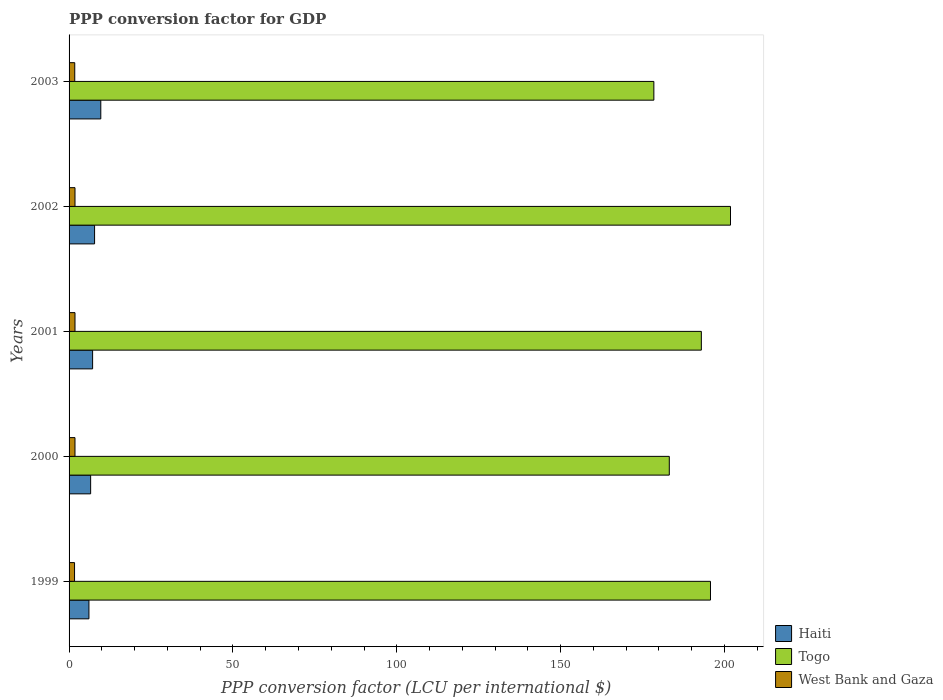How many different coloured bars are there?
Ensure brevity in your answer.  3. How many groups of bars are there?
Offer a terse response. 5. Are the number of bars per tick equal to the number of legend labels?
Your response must be concise. Yes. How many bars are there on the 2nd tick from the bottom?
Provide a succinct answer. 3. What is the label of the 5th group of bars from the top?
Your response must be concise. 1999. In how many cases, is the number of bars for a given year not equal to the number of legend labels?
Give a very brief answer. 0. What is the PPP conversion factor for GDP in West Bank and Gaza in 2001?
Keep it short and to the point. 1.81. Across all years, what is the maximum PPP conversion factor for GDP in Haiti?
Offer a terse response. 9.68. Across all years, what is the minimum PPP conversion factor for GDP in West Bank and Gaza?
Your answer should be very brief. 1.67. In which year was the PPP conversion factor for GDP in Togo maximum?
Provide a succinct answer. 2002. What is the total PPP conversion factor for GDP in Haiti in the graph?
Provide a short and direct response. 37.29. What is the difference between the PPP conversion factor for GDP in Togo in 1999 and that in 2002?
Offer a very short reply. -6.11. What is the difference between the PPP conversion factor for GDP in Haiti in 2000 and the PPP conversion factor for GDP in West Bank and Gaza in 2001?
Keep it short and to the point. 4.77. What is the average PPP conversion factor for GDP in West Bank and Gaza per year?
Offer a very short reply. 1.77. In the year 2002, what is the difference between the PPP conversion factor for GDP in Togo and PPP conversion factor for GDP in West Bank and Gaza?
Provide a succinct answer. 200.03. What is the ratio of the PPP conversion factor for GDP in Haiti in 2000 to that in 2002?
Offer a terse response. 0.85. What is the difference between the highest and the second highest PPP conversion factor for GDP in West Bank and Gaza?
Give a very brief answer. 0. What is the difference between the highest and the lowest PPP conversion factor for GDP in West Bank and Gaza?
Offer a terse response. 0.13. What does the 2nd bar from the top in 2001 represents?
Your answer should be very brief. Togo. What does the 1st bar from the bottom in 2002 represents?
Keep it short and to the point. Haiti. Are all the bars in the graph horizontal?
Your response must be concise. Yes. Does the graph contain any zero values?
Offer a very short reply. No. How are the legend labels stacked?
Give a very brief answer. Vertical. What is the title of the graph?
Offer a terse response. PPP conversion factor for GDP. What is the label or title of the X-axis?
Your response must be concise. PPP conversion factor (LCU per international $). What is the label or title of the Y-axis?
Your response must be concise. Years. What is the PPP conversion factor (LCU per international $) of Haiti in 1999?
Keep it short and to the point. 6.06. What is the PPP conversion factor (LCU per international $) of Togo in 1999?
Provide a succinct answer. 195.73. What is the PPP conversion factor (LCU per international $) in West Bank and Gaza in 1999?
Offer a very short reply. 1.67. What is the PPP conversion factor (LCU per international $) of Haiti in 2000?
Make the answer very short. 6.58. What is the PPP conversion factor (LCU per international $) in Togo in 2000?
Make the answer very short. 183.16. What is the PPP conversion factor (LCU per international $) in West Bank and Gaza in 2000?
Provide a succinct answer. 1.81. What is the PPP conversion factor (LCU per international $) in Haiti in 2001?
Make the answer very short. 7.18. What is the PPP conversion factor (LCU per international $) in Togo in 2001?
Your response must be concise. 192.94. What is the PPP conversion factor (LCU per international $) in West Bank and Gaza in 2001?
Keep it short and to the point. 1.81. What is the PPP conversion factor (LCU per international $) of Haiti in 2002?
Offer a very short reply. 7.78. What is the PPP conversion factor (LCU per international $) in Togo in 2002?
Your answer should be compact. 201.84. What is the PPP conversion factor (LCU per international $) of West Bank and Gaza in 2002?
Keep it short and to the point. 1.81. What is the PPP conversion factor (LCU per international $) in Haiti in 2003?
Your response must be concise. 9.68. What is the PPP conversion factor (LCU per international $) of Togo in 2003?
Give a very brief answer. 178.45. What is the PPP conversion factor (LCU per international $) in West Bank and Gaza in 2003?
Ensure brevity in your answer.  1.73. Across all years, what is the maximum PPP conversion factor (LCU per international $) in Haiti?
Your answer should be very brief. 9.68. Across all years, what is the maximum PPP conversion factor (LCU per international $) of Togo?
Your answer should be compact. 201.84. Across all years, what is the maximum PPP conversion factor (LCU per international $) in West Bank and Gaza?
Your answer should be compact. 1.81. Across all years, what is the minimum PPP conversion factor (LCU per international $) in Haiti?
Give a very brief answer. 6.06. Across all years, what is the minimum PPP conversion factor (LCU per international $) of Togo?
Provide a succinct answer. 178.45. Across all years, what is the minimum PPP conversion factor (LCU per international $) in West Bank and Gaza?
Your response must be concise. 1.67. What is the total PPP conversion factor (LCU per international $) of Haiti in the graph?
Your answer should be compact. 37.29. What is the total PPP conversion factor (LCU per international $) of Togo in the graph?
Keep it short and to the point. 952.13. What is the total PPP conversion factor (LCU per international $) in West Bank and Gaza in the graph?
Your answer should be very brief. 8.83. What is the difference between the PPP conversion factor (LCU per international $) in Haiti in 1999 and that in 2000?
Your answer should be very brief. -0.52. What is the difference between the PPP conversion factor (LCU per international $) in Togo in 1999 and that in 2000?
Offer a terse response. 12.57. What is the difference between the PPP conversion factor (LCU per international $) in West Bank and Gaza in 1999 and that in 2000?
Ensure brevity in your answer.  -0.13. What is the difference between the PPP conversion factor (LCU per international $) in Haiti in 1999 and that in 2001?
Your response must be concise. -1.12. What is the difference between the PPP conversion factor (LCU per international $) of Togo in 1999 and that in 2001?
Make the answer very short. 2.79. What is the difference between the PPP conversion factor (LCU per international $) of West Bank and Gaza in 1999 and that in 2001?
Give a very brief answer. -0.13. What is the difference between the PPP conversion factor (LCU per international $) in Haiti in 1999 and that in 2002?
Give a very brief answer. -1.72. What is the difference between the PPP conversion factor (LCU per international $) of Togo in 1999 and that in 2002?
Provide a short and direct response. -6.11. What is the difference between the PPP conversion factor (LCU per international $) in West Bank and Gaza in 1999 and that in 2002?
Offer a terse response. -0.13. What is the difference between the PPP conversion factor (LCU per international $) of Haiti in 1999 and that in 2003?
Offer a terse response. -3.62. What is the difference between the PPP conversion factor (LCU per international $) in Togo in 1999 and that in 2003?
Provide a succinct answer. 17.28. What is the difference between the PPP conversion factor (LCU per international $) of West Bank and Gaza in 1999 and that in 2003?
Give a very brief answer. -0.06. What is the difference between the PPP conversion factor (LCU per international $) of Haiti in 2000 and that in 2001?
Make the answer very short. -0.6. What is the difference between the PPP conversion factor (LCU per international $) of Togo in 2000 and that in 2001?
Give a very brief answer. -9.78. What is the difference between the PPP conversion factor (LCU per international $) of West Bank and Gaza in 2000 and that in 2001?
Give a very brief answer. -0. What is the difference between the PPP conversion factor (LCU per international $) in Haiti in 2000 and that in 2002?
Keep it short and to the point. -1.2. What is the difference between the PPP conversion factor (LCU per international $) in Togo in 2000 and that in 2002?
Offer a very short reply. -18.68. What is the difference between the PPP conversion factor (LCU per international $) in West Bank and Gaza in 2000 and that in 2002?
Offer a very short reply. -0. What is the difference between the PPP conversion factor (LCU per international $) in Haiti in 2000 and that in 2003?
Your response must be concise. -3.1. What is the difference between the PPP conversion factor (LCU per international $) in Togo in 2000 and that in 2003?
Offer a very short reply. 4.71. What is the difference between the PPP conversion factor (LCU per international $) in West Bank and Gaza in 2000 and that in 2003?
Keep it short and to the point. 0.07. What is the difference between the PPP conversion factor (LCU per international $) of Haiti in 2001 and that in 2002?
Provide a short and direct response. -0.6. What is the difference between the PPP conversion factor (LCU per international $) of Togo in 2001 and that in 2002?
Ensure brevity in your answer.  -8.9. What is the difference between the PPP conversion factor (LCU per international $) of West Bank and Gaza in 2001 and that in 2002?
Provide a short and direct response. 0. What is the difference between the PPP conversion factor (LCU per international $) of Haiti in 2001 and that in 2003?
Give a very brief answer. -2.5. What is the difference between the PPP conversion factor (LCU per international $) in Togo in 2001 and that in 2003?
Give a very brief answer. 14.49. What is the difference between the PPP conversion factor (LCU per international $) of West Bank and Gaza in 2001 and that in 2003?
Provide a succinct answer. 0.07. What is the difference between the PPP conversion factor (LCU per international $) in Haiti in 2002 and that in 2003?
Ensure brevity in your answer.  -1.9. What is the difference between the PPP conversion factor (LCU per international $) of Togo in 2002 and that in 2003?
Provide a succinct answer. 23.39. What is the difference between the PPP conversion factor (LCU per international $) of West Bank and Gaza in 2002 and that in 2003?
Offer a terse response. 0.07. What is the difference between the PPP conversion factor (LCU per international $) in Haiti in 1999 and the PPP conversion factor (LCU per international $) in Togo in 2000?
Ensure brevity in your answer.  -177.1. What is the difference between the PPP conversion factor (LCU per international $) in Haiti in 1999 and the PPP conversion factor (LCU per international $) in West Bank and Gaza in 2000?
Make the answer very short. 4.25. What is the difference between the PPP conversion factor (LCU per international $) of Togo in 1999 and the PPP conversion factor (LCU per international $) of West Bank and Gaza in 2000?
Offer a very short reply. 193.92. What is the difference between the PPP conversion factor (LCU per international $) of Haiti in 1999 and the PPP conversion factor (LCU per international $) of Togo in 2001?
Provide a succinct answer. -186.88. What is the difference between the PPP conversion factor (LCU per international $) in Haiti in 1999 and the PPP conversion factor (LCU per international $) in West Bank and Gaza in 2001?
Keep it short and to the point. 4.25. What is the difference between the PPP conversion factor (LCU per international $) in Togo in 1999 and the PPP conversion factor (LCU per international $) in West Bank and Gaza in 2001?
Keep it short and to the point. 193.92. What is the difference between the PPP conversion factor (LCU per international $) of Haiti in 1999 and the PPP conversion factor (LCU per international $) of Togo in 2002?
Make the answer very short. -195.78. What is the difference between the PPP conversion factor (LCU per international $) of Haiti in 1999 and the PPP conversion factor (LCU per international $) of West Bank and Gaza in 2002?
Provide a succinct answer. 4.25. What is the difference between the PPP conversion factor (LCU per international $) in Togo in 1999 and the PPP conversion factor (LCU per international $) in West Bank and Gaza in 2002?
Provide a succinct answer. 193.92. What is the difference between the PPP conversion factor (LCU per international $) of Haiti in 1999 and the PPP conversion factor (LCU per international $) of Togo in 2003?
Offer a very short reply. -172.39. What is the difference between the PPP conversion factor (LCU per international $) in Haiti in 1999 and the PPP conversion factor (LCU per international $) in West Bank and Gaza in 2003?
Make the answer very short. 4.33. What is the difference between the PPP conversion factor (LCU per international $) in Togo in 1999 and the PPP conversion factor (LCU per international $) in West Bank and Gaza in 2003?
Make the answer very short. 194. What is the difference between the PPP conversion factor (LCU per international $) of Haiti in 2000 and the PPP conversion factor (LCU per international $) of Togo in 2001?
Offer a terse response. -186.36. What is the difference between the PPP conversion factor (LCU per international $) of Haiti in 2000 and the PPP conversion factor (LCU per international $) of West Bank and Gaza in 2001?
Ensure brevity in your answer.  4.77. What is the difference between the PPP conversion factor (LCU per international $) of Togo in 2000 and the PPP conversion factor (LCU per international $) of West Bank and Gaza in 2001?
Your answer should be very brief. 181.36. What is the difference between the PPP conversion factor (LCU per international $) of Haiti in 2000 and the PPP conversion factor (LCU per international $) of Togo in 2002?
Your response must be concise. -195.26. What is the difference between the PPP conversion factor (LCU per international $) of Haiti in 2000 and the PPP conversion factor (LCU per international $) of West Bank and Gaza in 2002?
Ensure brevity in your answer.  4.77. What is the difference between the PPP conversion factor (LCU per international $) in Togo in 2000 and the PPP conversion factor (LCU per international $) in West Bank and Gaza in 2002?
Ensure brevity in your answer.  181.36. What is the difference between the PPP conversion factor (LCU per international $) in Haiti in 2000 and the PPP conversion factor (LCU per international $) in Togo in 2003?
Offer a terse response. -171.87. What is the difference between the PPP conversion factor (LCU per international $) in Haiti in 2000 and the PPP conversion factor (LCU per international $) in West Bank and Gaza in 2003?
Provide a short and direct response. 4.85. What is the difference between the PPP conversion factor (LCU per international $) of Togo in 2000 and the PPP conversion factor (LCU per international $) of West Bank and Gaza in 2003?
Provide a short and direct response. 181.43. What is the difference between the PPP conversion factor (LCU per international $) of Haiti in 2001 and the PPP conversion factor (LCU per international $) of Togo in 2002?
Keep it short and to the point. -194.66. What is the difference between the PPP conversion factor (LCU per international $) of Haiti in 2001 and the PPP conversion factor (LCU per international $) of West Bank and Gaza in 2002?
Your answer should be very brief. 5.38. What is the difference between the PPP conversion factor (LCU per international $) in Togo in 2001 and the PPP conversion factor (LCU per international $) in West Bank and Gaza in 2002?
Your answer should be very brief. 191.14. What is the difference between the PPP conversion factor (LCU per international $) of Haiti in 2001 and the PPP conversion factor (LCU per international $) of Togo in 2003?
Give a very brief answer. -171.27. What is the difference between the PPP conversion factor (LCU per international $) in Haiti in 2001 and the PPP conversion factor (LCU per international $) in West Bank and Gaza in 2003?
Ensure brevity in your answer.  5.45. What is the difference between the PPP conversion factor (LCU per international $) of Togo in 2001 and the PPP conversion factor (LCU per international $) of West Bank and Gaza in 2003?
Your response must be concise. 191.21. What is the difference between the PPP conversion factor (LCU per international $) in Haiti in 2002 and the PPP conversion factor (LCU per international $) in Togo in 2003?
Your answer should be compact. -170.67. What is the difference between the PPP conversion factor (LCU per international $) in Haiti in 2002 and the PPP conversion factor (LCU per international $) in West Bank and Gaza in 2003?
Ensure brevity in your answer.  6.05. What is the difference between the PPP conversion factor (LCU per international $) in Togo in 2002 and the PPP conversion factor (LCU per international $) in West Bank and Gaza in 2003?
Provide a short and direct response. 200.11. What is the average PPP conversion factor (LCU per international $) of Haiti per year?
Your response must be concise. 7.46. What is the average PPP conversion factor (LCU per international $) of Togo per year?
Your response must be concise. 190.43. What is the average PPP conversion factor (LCU per international $) in West Bank and Gaza per year?
Offer a terse response. 1.77. In the year 1999, what is the difference between the PPP conversion factor (LCU per international $) in Haiti and PPP conversion factor (LCU per international $) in Togo?
Make the answer very short. -189.67. In the year 1999, what is the difference between the PPP conversion factor (LCU per international $) of Haiti and PPP conversion factor (LCU per international $) of West Bank and Gaza?
Provide a short and direct response. 4.39. In the year 1999, what is the difference between the PPP conversion factor (LCU per international $) of Togo and PPP conversion factor (LCU per international $) of West Bank and Gaza?
Your answer should be very brief. 194.06. In the year 2000, what is the difference between the PPP conversion factor (LCU per international $) of Haiti and PPP conversion factor (LCU per international $) of Togo?
Ensure brevity in your answer.  -176.58. In the year 2000, what is the difference between the PPP conversion factor (LCU per international $) in Haiti and PPP conversion factor (LCU per international $) in West Bank and Gaza?
Make the answer very short. 4.77. In the year 2000, what is the difference between the PPP conversion factor (LCU per international $) of Togo and PPP conversion factor (LCU per international $) of West Bank and Gaza?
Provide a succinct answer. 181.36. In the year 2001, what is the difference between the PPP conversion factor (LCU per international $) of Haiti and PPP conversion factor (LCU per international $) of Togo?
Your response must be concise. -185.76. In the year 2001, what is the difference between the PPP conversion factor (LCU per international $) in Haiti and PPP conversion factor (LCU per international $) in West Bank and Gaza?
Your answer should be compact. 5.38. In the year 2001, what is the difference between the PPP conversion factor (LCU per international $) in Togo and PPP conversion factor (LCU per international $) in West Bank and Gaza?
Ensure brevity in your answer.  191.14. In the year 2002, what is the difference between the PPP conversion factor (LCU per international $) of Haiti and PPP conversion factor (LCU per international $) of Togo?
Give a very brief answer. -194.06. In the year 2002, what is the difference between the PPP conversion factor (LCU per international $) of Haiti and PPP conversion factor (LCU per international $) of West Bank and Gaza?
Make the answer very short. 5.98. In the year 2002, what is the difference between the PPP conversion factor (LCU per international $) of Togo and PPP conversion factor (LCU per international $) of West Bank and Gaza?
Ensure brevity in your answer.  200.03. In the year 2003, what is the difference between the PPP conversion factor (LCU per international $) in Haiti and PPP conversion factor (LCU per international $) in Togo?
Provide a succinct answer. -168.77. In the year 2003, what is the difference between the PPP conversion factor (LCU per international $) of Haiti and PPP conversion factor (LCU per international $) of West Bank and Gaza?
Your answer should be compact. 7.95. In the year 2003, what is the difference between the PPP conversion factor (LCU per international $) in Togo and PPP conversion factor (LCU per international $) in West Bank and Gaza?
Your answer should be very brief. 176.72. What is the ratio of the PPP conversion factor (LCU per international $) in Haiti in 1999 to that in 2000?
Your response must be concise. 0.92. What is the ratio of the PPP conversion factor (LCU per international $) in Togo in 1999 to that in 2000?
Ensure brevity in your answer.  1.07. What is the ratio of the PPP conversion factor (LCU per international $) of West Bank and Gaza in 1999 to that in 2000?
Keep it short and to the point. 0.93. What is the ratio of the PPP conversion factor (LCU per international $) of Haiti in 1999 to that in 2001?
Provide a short and direct response. 0.84. What is the ratio of the PPP conversion factor (LCU per international $) in Togo in 1999 to that in 2001?
Your answer should be very brief. 1.01. What is the ratio of the PPP conversion factor (LCU per international $) of West Bank and Gaza in 1999 to that in 2001?
Your answer should be compact. 0.93. What is the ratio of the PPP conversion factor (LCU per international $) in Haiti in 1999 to that in 2002?
Provide a succinct answer. 0.78. What is the ratio of the PPP conversion factor (LCU per international $) in Togo in 1999 to that in 2002?
Your answer should be compact. 0.97. What is the ratio of the PPP conversion factor (LCU per international $) of West Bank and Gaza in 1999 to that in 2002?
Make the answer very short. 0.93. What is the ratio of the PPP conversion factor (LCU per international $) in Haiti in 1999 to that in 2003?
Your answer should be very brief. 0.63. What is the ratio of the PPP conversion factor (LCU per international $) in Togo in 1999 to that in 2003?
Your response must be concise. 1.1. What is the ratio of the PPP conversion factor (LCU per international $) in West Bank and Gaza in 1999 to that in 2003?
Offer a terse response. 0.96. What is the ratio of the PPP conversion factor (LCU per international $) in Haiti in 2000 to that in 2001?
Your answer should be very brief. 0.92. What is the ratio of the PPP conversion factor (LCU per international $) in Togo in 2000 to that in 2001?
Ensure brevity in your answer.  0.95. What is the ratio of the PPP conversion factor (LCU per international $) of West Bank and Gaza in 2000 to that in 2001?
Make the answer very short. 1. What is the ratio of the PPP conversion factor (LCU per international $) of Haiti in 2000 to that in 2002?
Your answer should be very brief. 0.85. What is the ratio of the PPP conversion factor (LCU per international $) in Togo in 2000 to that in 2002?
Keep it short and to the point. 0.91. What is the ratio of the PPP conversion factor (LCU per international $) in Haiti in 2000 to that in 2003?
Provide a succinct answer. 0.68. What is the ratio of the PPP conversion factor (LCU per international $) of Togo in 2000 to that in 2003?
Provide a short and direct response. 1.03. What is the ratio of the PPP conversion factor (LCU per international $) in West Bank and Gaza in 2000 to that in 2003?
Your response must be concise. 1.04. What is the ratio of the PPP conversion factor (LCU per international $) of Haiti in 2001 to that in 2002?
Keep it short and to the point. 0.92. What is the ratio of the PPP conversion factor (LCU per international $) of Togo in 2001 to that in 2002?
Make the answer very short. 0.96. What is the ratio of the PPP conversion factor (LCU per international $) in Haiti in 2001 to that in 2003?
Offer a terse response. 0.74. What is the ratio of the PPP conversion factor (LCU per international $) of Togo in 2001 to that in 2003?
Ensure brevity in your answer.  1.08. What is the ratio of the PPP conversion factor (LCU per international $) of West Bank and Gaza in 2001 to that in 2003?
Keep it short and to the point. 1.04. What is the ratio of the PPP conversion factor (LCU per international $) of Haiti in 2002 to that in 2003?
Your answer should be very brief. 0.8. What is the ratio of the PPP conversion factor (LCU per international $) of Togo in 2002 to that in 2003?
Offer a terse response. 1.13. What is the ratio of the PPP conversion factor (LCU per international $) in West Bank and Gaza in 2002 to that in 2003?
Provide a succinct answer. 1.04. What is the difference between the highest and the second highest PPP conversion factor (LCU per international $) of Haiti?
Your answer should be very brief. 1.9. What is the difference between the highest and the second highest PPP conversion factor (LCU per international $) in Togo?
Provide a short and direct response. 6.11. What is the difference between the highest and the second highest PPP conversion factor (LCU per international $) of West Bank and Gaza?
Provide a short and direct response. 0. What is the difference between the highest and the lowest PPP conversion factor (LCU per international $) in Haiti?
Make the answer very short. 3.62. What is the difference between the highest and the lowest PPP conversion factor (LCU per international $) in Togo?
Offer a terse response. 23.39. What is the difference between the highest and the lowest PPP conversion factor (LCU per international $) in West Bank and Gaza?
Make the answer very short. 0.13. 